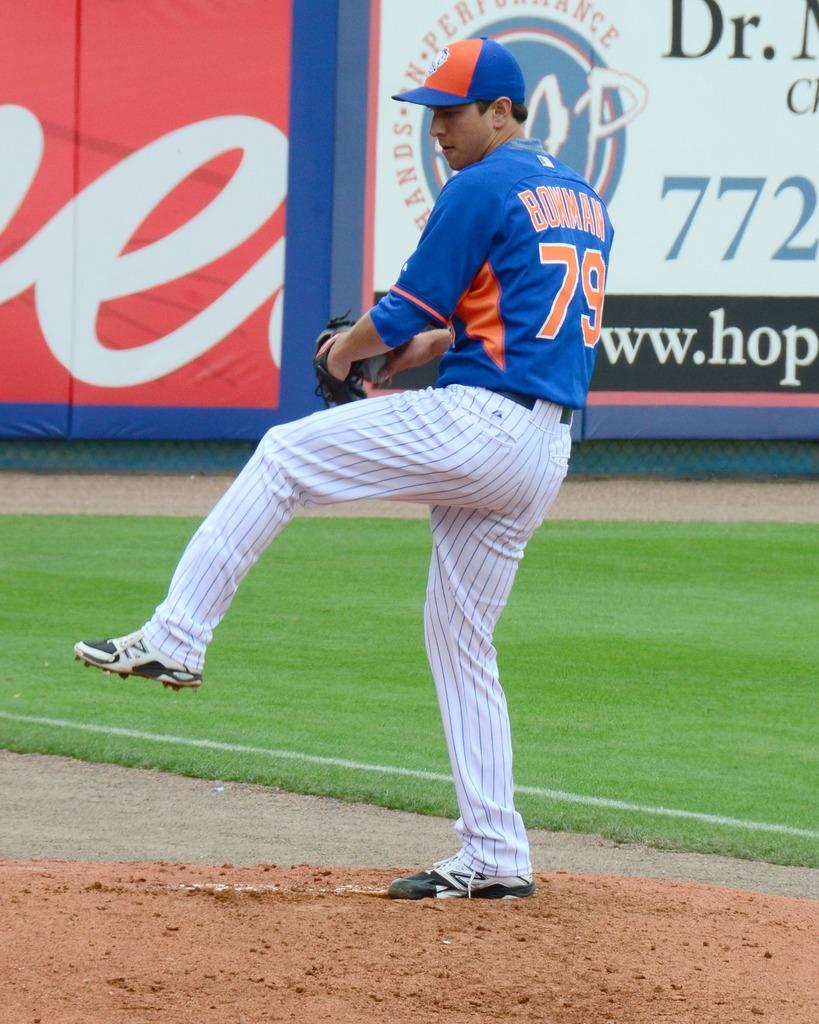<image>
Present a compact description of the photo's key features. a player with the number 79 on the back of it 